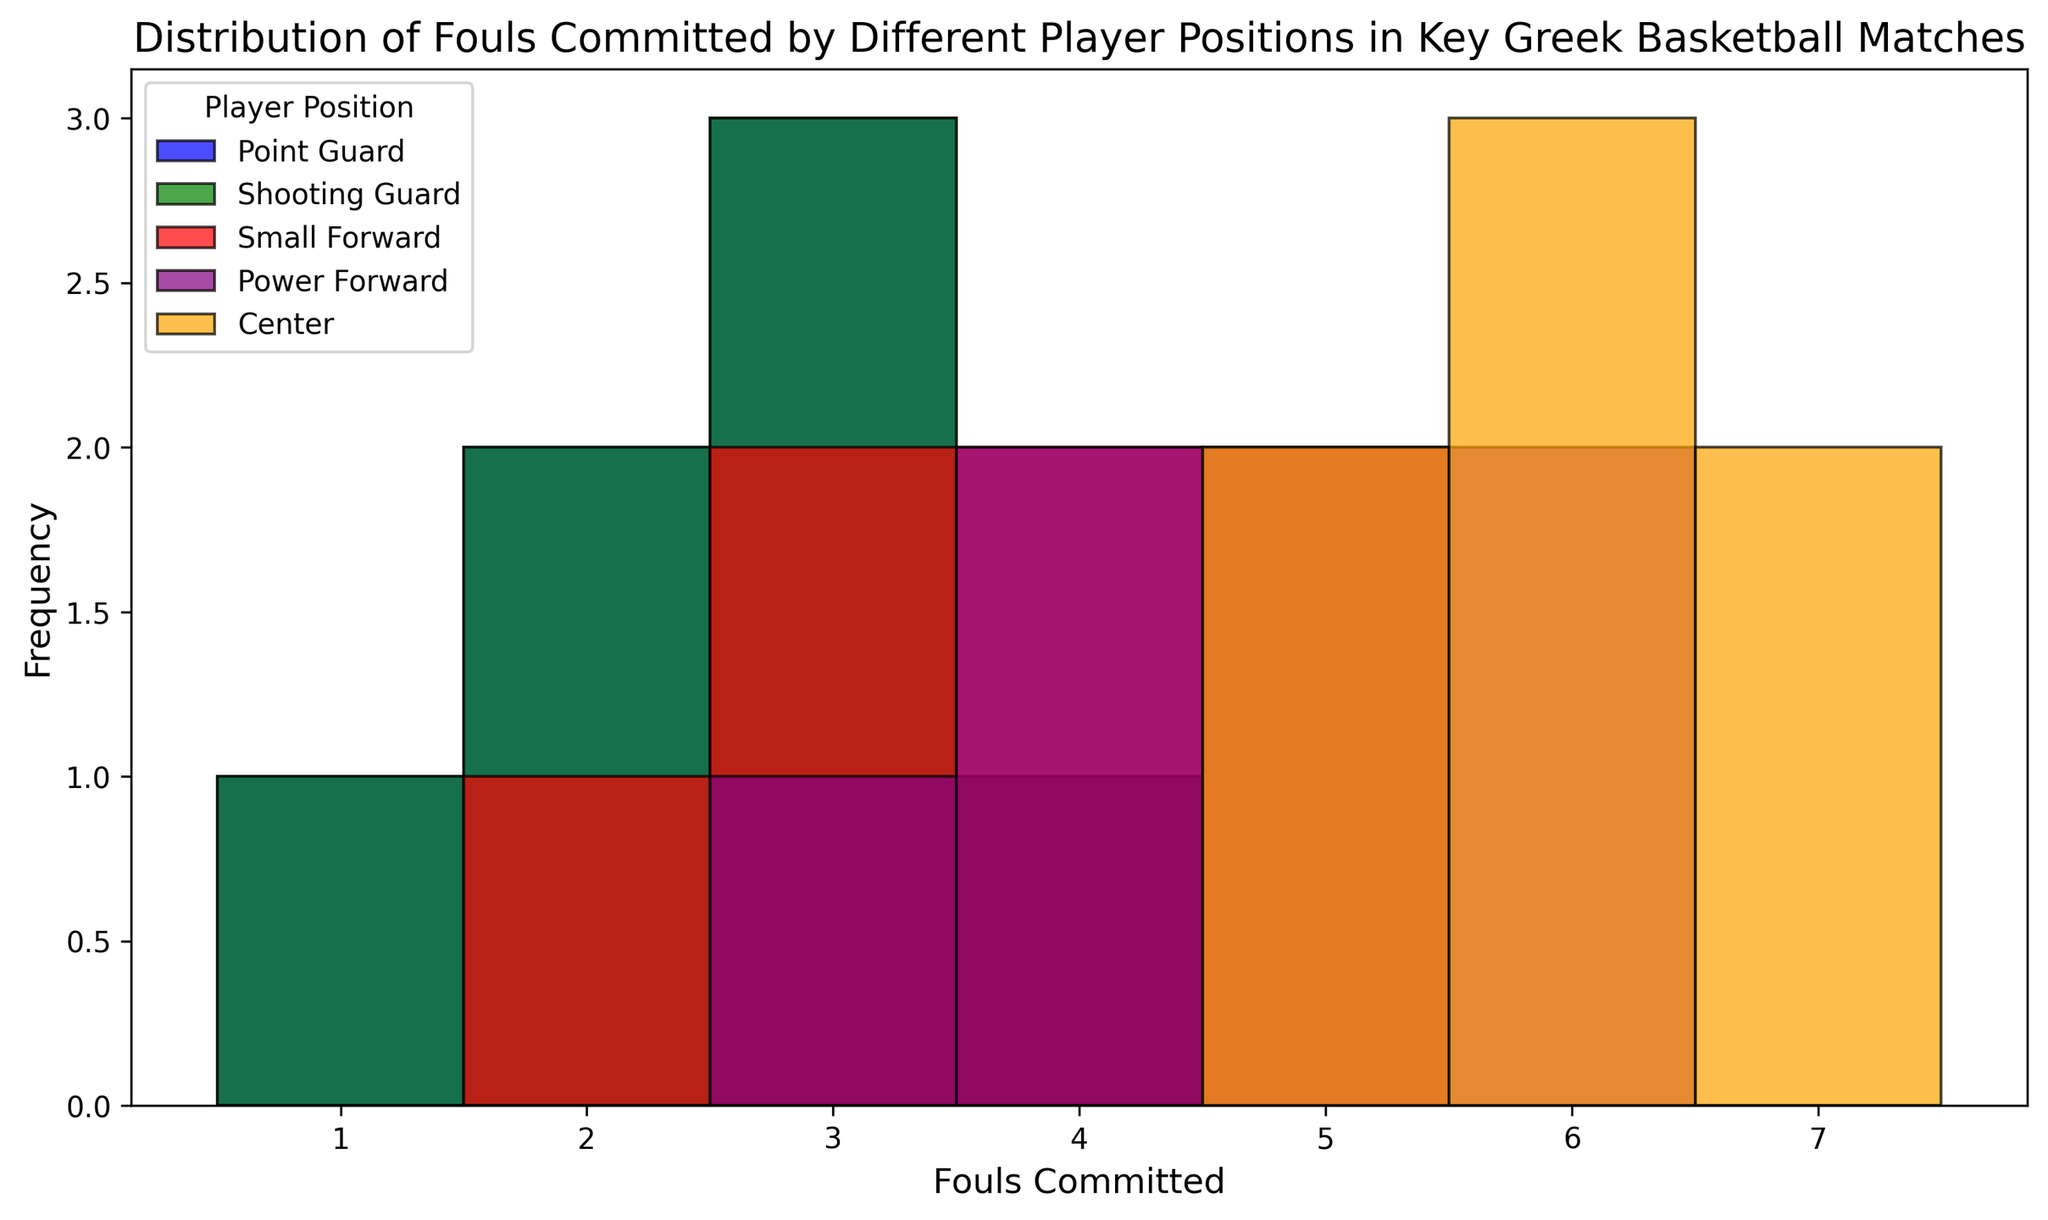Which player position has the highest frequency of fouls at 6? To find the position with the highest frequency at 6 fouls, look at the bar heights for each position at the 6 fouls mark and compare them. The highest bar at 6 fouls belongs to the Center position.
Answer: Center How many different player positions have committed exactly 4 fouls? Count the number of different bars at the 4 fouls mark. The positions with bars at 4 fouls are Small Forward, Power Forward, and Point Guard, totaling 3 positions.
Answer: 3 Which player position has the widest range of fouls committed? Look at the spread of the fouls committed for each position. The Center position has a range from 5 to 7 fouls, while the Point Guard ranges from 1 to 4. Track the widest span. Center has the widest range, from 3 to 7.
Answer: Center What is the most common number of fouls committed by Power Forwards? By examining the histogram heights, identify the tallest bar for the Power Forward position. The tallest bar for Power Forward is at 6 fouls.
Answer: 6 Are there more players committing 5 fouls as Point Guards or Centers? Compare the heights of the bars at 5 fouls for Point Guards and Centers. The bar for Centers is higher at 5 fouls than that for Point Guards.
Answer: Centers 